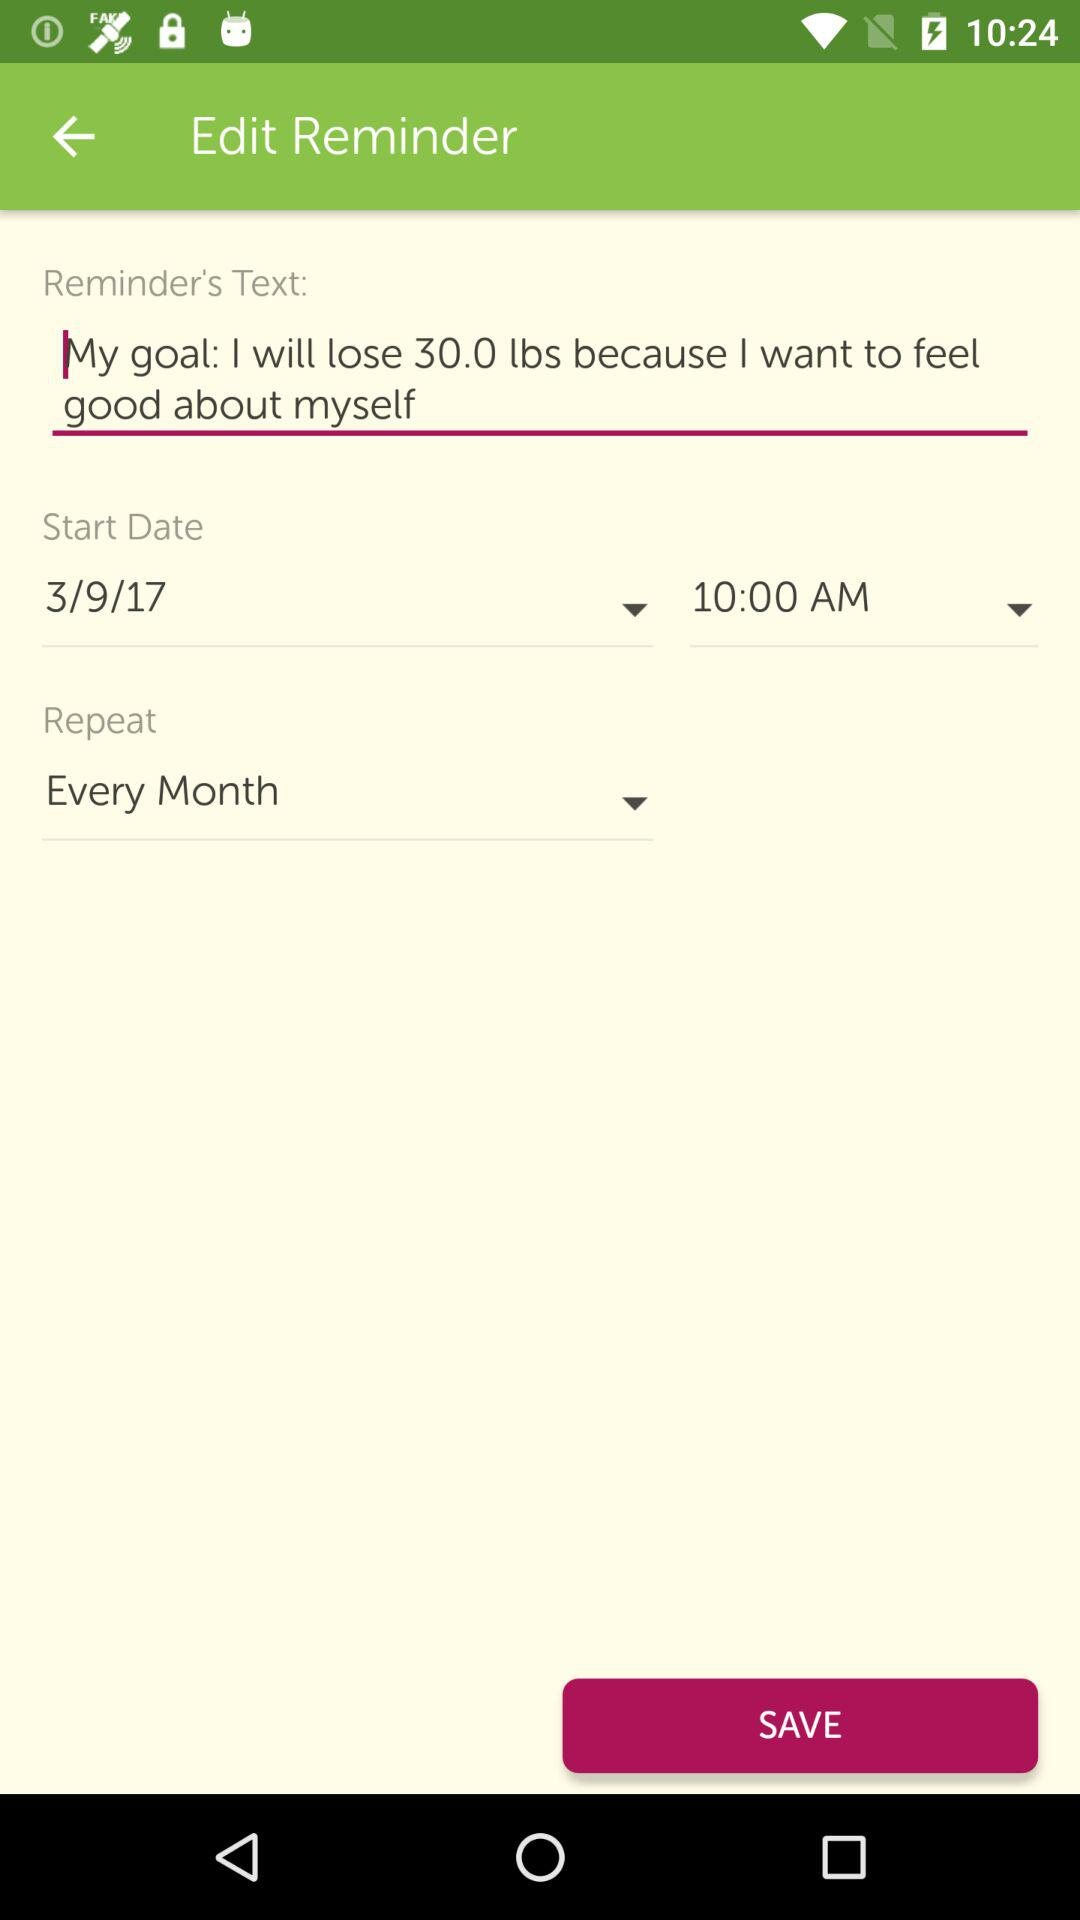What date is the reminder set for?
Answer the question using a single word or phrase. 3/9/17 